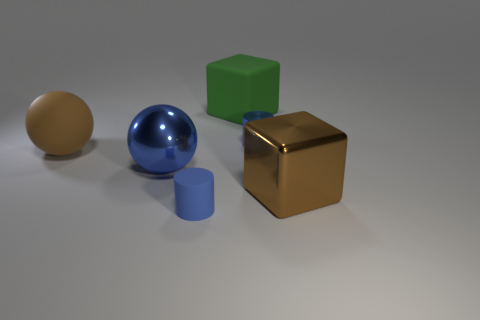Add 3 big brown spheres. How many objects exist? 9 Subtract all cylinders. How many objects are left? 4 Subtract all big balls. Subtract all big shiny objects. How many objects are left? 2 Add 6 blue rubber things. How many blue rubber things are left? 7 Add 6 small cyan blocks. How many small cyan blocks exist? 6 Subtract 0 blue cubes. How many objects are left? 6 